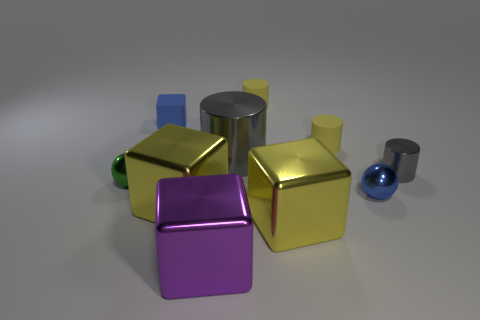Subtract all small blue rubber cubes. How many cubes are left? 3 Subtract all purple cubes. How many gray cylinders are left? 2 Subtract all gray cylinders. How many cylinders are left? 2 Subtract all balls. How many objects are left? 8 Add 5 big cylinders. How many big cylinders are left? 6 Add 1 tiny yellow matte objects. How many tiny yellow matte objects exist? 3 Subtract 0 red cylinders. How many objects are left? 10 Subtract all blue cubes. Subtract all blue spheres. How many cubes are left? 3 Subtract all purple shiny things. Subtract all large shiny blocks. How many objects are left? 6 